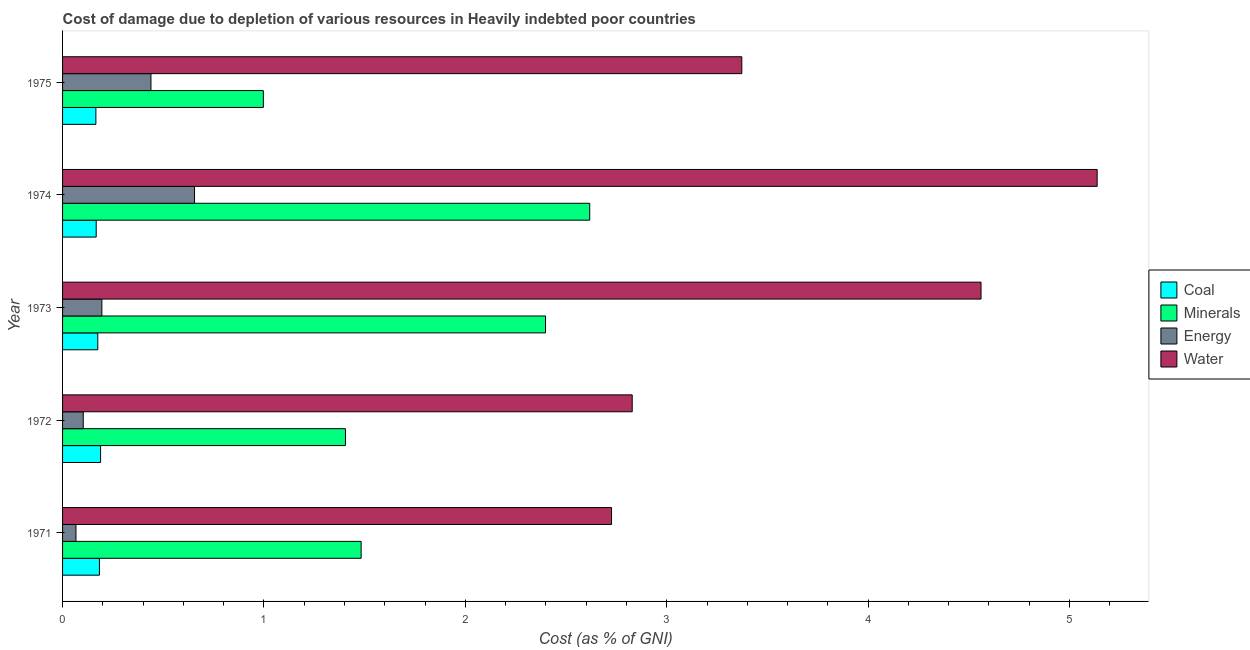How many groups of bars are there?
Your answer should be compact. 5. Are the number of bars on each tick of the Y-axis equal?
Make the answer very short. Yes. How many bars are there on the 3rd tick from the bottom?
Give a very brief answer. 4. In how many cases, is the number of bars for a given year not equal to the number of legend labels?
Offer a very short reply. 0. What is the cost of damage due to depletion of energy in 1975?
Ensure brevity in your answer.  0.44. Across all years, what is the maximum cost of damage due to depletion of energy?
Your answer should be very brief. 0.66. Across all years, what is the minimum cost of damage due to depletion of energy?
Ensure brevity in your answer.  0.07. In which year was the cost of damage due to depletion of water maximum?
Provide a short and direct response. 1974. What is the total cost of damage due to depletion of water in the graph?
Keep it short and to the point. 18.63. What is the difference between the cost of damage due to depletion of energy in 1972 and that in 1973?
Keep it short and to the point. -0.09. What is the difference between the cost of damage due to depletion of energy in 1972 and the cost of damage due to depletion of minerals in 1974?
Keep it short and to the point. -2.51. What is the average cost of damage due to depletion of minerals per year?
Keep it short and to the point. 1.78. In the year 1972, what is the difference between the cost of damage due to depletion of energy and cost of damage due to depletion of coal?
Give a very brief answer. -0.09. What is the ratio of the cost of damage due to depletion of coal in 1972 to that in 1974?
Keep it short and to the point. 1.13. Is the difference between the cost of damage due to depletion of minerals in 1972 and 1975 greater than the difference between the cost of damage due to depletion of energy in 1972 and 1975?
Give a very brief answer. Yes. What is the difference between the highest and the second highest cost of damage due to depletion of water?
Make the answer very short. 0.58. What is the difference between the highest and the lowest cost of damage due to depletion of water?
Keep it short and to the point. 2.41. In how many years, is the cost of damage due to depletion of coal greater than the average cost of damage due to depletion of coal taken over all years?
Make the answer very short. 2. Is the sum of the cost of damage due to depletion of energy in 1972 and 1975 greater than the maximum cost of damage due to depletion of minerals across all years?
Ensure brevity in your answer.  No. Is it the case that in every year, the sum of the cost of damage due to depletion of water and cost of damage due to depletion of energy is greater than the sum of cost of damage due to depletion of coal and cost of damage due to depletion of minerals?
Your answer should be very brief. Yes. What does the 2nd bar from the top in 1973 represents?
Your answer should be compact. Energy. What does the 3rd bar from the bottom in 1972 represents?
Give a very brief answer. Energy. How many years are there in the graph?
Provide a short and direct response. 5. Are the values on the major ticks of X-axis written in scientific E-notation?
Ensure brevity in your answer.  No. Does the graph contain any zero values?
Ensure brevity in your answer.  No. How many legend labels are there?
Offer a very short reply. 4. What is the title of the graph?
Provide a short and direct response. Cost of damage due to depletion of various resources in Heavily indebted poor countries . What is the label or title of the X-axis?
Your response must be concise. Cost (as % of GNI). What is the label or title of the Y-axis?
Keep it short and to the point. Year. What is the Cost (as % of GNI) in Coal in 1971?
Offer a terse response. 0.18. What is the Cost (as % of GNI) in Minerals in 1971?
Your answer should be very brief. 1.48. What is the Cost (as % of GNI) in Energy in 1971?
Make the answer very short. 0.07. What is the Cost (as % of GNI) in Water in 1971?
Your answer should be very brief. 2.73. What is the Cost (as % of GNI) in Coal in 1972?
Your answer should be compact. 0.19. What is the Cost (as % of GNI) in Minerals in 1972?
Your response must be concise. 1.4. What is the Cost (as % of GNI) in Energy in 1972?
Ensure brevity in your answer.  0.1. What is the Cost (as % of GNI) in Water in 1972?
Provide a short and direct response. 2.83. What is the Cost (as % of GNI) of Coal in 1973?
Provide a succinct answer. 0.17. What is the Cost (as % of GNI) in Minerals in 1973?
Your answer should be compact. 2.4. What is the Cost (as % of GNI) in Energy in 1973?
Your answer should be very brief. 0.2. What is the Cost (as % of GNI) of Water in 1973?
Keep it short and to the point. 4.56. What is the Cost (as % of GNI) of Coal in 1974?
Ensure brevity in your answer.  0.17. What is the Cost (as % of GNI) of Minerals in 1974?
Make the answer very short. 2.62. What is the Cost (as % of GNI) in Energy in 1974?
Keep it short and to the point. 0.66. What is the Cost (as % of GNI) of Water in 1974?
Your response must be concise. 5.14. What is the Cost (as % of GNI) of Coal in 1975?
Give a very brief answer. 0.17. What is the Cost (as % of GNI) in Minerals in 1975?
Your response must be concise. 1. What is the Cost (as % of GNI) in Energy in 1975?
Your answer should be compact. 0.44. What is the Cost (as % of GNI) of Water in 1975?
Keep it short and to the point. 3.37. Across all years, what is the maximum Cost (as % of GNI) of Coal?
Ensure brevity in your answer.  0.19. Across all years, what is the maximum Cost (as % of GNI) in Minerals?
Your answer should be very brief. 2.62. Across all years, what is the maximum Cost (as % of GNI) of Energy?
Make the answer very short. 0.66. Across all years, what is the maximum Cost (as % of GNI) of Water?
Your answer should be compact. 5.14. Across all years, what is the minimum Cost (as % of GNI) of Coal?
Give a very brief answer. 0.17. Across all years, what is the minimum Cost (as % of GNI) in Minerals?
Offer a terse response. 1. Across all years, what is the minimum Cost (as % of GNI) of Energy?
Offer a terse response. 0.07. Across all years, what is the minimum Cost (as % of GNI) of Water?
Provide a short and direct response. 2.73. What is the total Cost (as % of GNI) in Coal in the graph?
Your response must be concise. 0.88. What is the total Cost (as % of GNI) in Minerals in the graph?
Make the answer very short. 8.9. What is the total Cost (as % of GNI) in Energy in the graph?
Keep it short and to the point. 1.46. What is the total Cost (as % of GNI) of Water in the graph?
Your response must be concise. 18.63. What is the difference between the Cost (as % of GNI) in Coal in 1971 and that in 1972?
Keep it short and to the point. -0.01. What is the difference between the Cost (as % of GNI) of Minerals in 1971 and that in 1972?
Provide a short and direct response. 0.08. What is the difference between the Cost (as % of GNI) in Energy in 1971 and that in 1972?
Give a very brief answer. -0.04. What is the difference between the Cost (as % of GNI) of Water in 1971 and that in 1972?
Offer a very short reply. -0.1. What is the difference between the Cost (as % of GNI) of Coal in 1971 and that in 1973?
Your answer should be very brief. 0.01. What is the difference between the Cost (as % of GNI) of Minerals in 1971 and that in 1973?
Make the answer very short. -0.92. What is the difference between the Cost (as % of GNI) in Energy in 1971 and that in 1973?
Your answer should be very brief. -0.13. What is the difference between the Cost (as % of GNI) of Water in 1971 and that in 1973?
Give a very brief answer. -1.83. What is the difference between the Cost (as % of GNI) in Coal in 1971 and that in 1974?
Ensure brevity in your answer.  0.02. What is the difference between the Cost (as % of GNI) in Minerals in 1971 and that in 1974?
Provide a short and direct response. -1.14. What is the difference between the Cost (as % of GNI) in Energy in 1971 and that in 1974?
Keep it short and to the point. -0.59. What is the difference between the Cost (as % of GNI) in Water in 1971 and that in 1974?
Provide a short and direct response. -2.41. What is the difference between the Cost (as % of GNI) in Coal in 1971 and that in 1975?
Offer a very short reply. 0.02. What is the difference between the Cost (as % of GNI) in Minerals in 1971 and that in 1975?
Your answer should be compact. 0.49. What is the difference between the Cost (as % of GNI) of Energy in 1971 and that in 1975?
Your response must be concise. -0.37. What is the difference between the Cost (as % of GNI) in Water in 1971 and that in 1975?
Provide a short and direct response. -0.65. What is the difference between the Cost (as % of GNI) of Coal in 1972 and that in 1973?
Provide a short and direct response. 0.01. What is the difference between the Cost (as % of GNI) of Minerals in 1972 and that in 1973?
Your answer should be very brief. -0.99. What is the difference between the Cost (as % of GNI) in Energy in 1972 and that in 1973?
Keep it short and to the point. -0.09. What is the difference between the Cost (as % of GNI) of Water in 1972 and that in 1973?
Ensure brevity in your answer.  -1.73. What is the difference between the Cost (as % of GNI) in Coal in 1972 and that in 1974?
Your response must be concise. 0.02. What is the difference between the Cost (as % of GNI) of Minerals in 1972 and that in 1974?
Provide a short and direct response. -1.21. What is the difference between the Cost (as % of GNI) in Energy in 1972 and that in 1974?
Your response must be concise. -0.55. What is the difference between the Cost (as % of GNI) in Water in 1972 and that in 1974?
Provide a succinct answer. -2.31. What is the difference between the Cost (as % of GNI) of Coal in 1972 and that in 1975?
Your response must be concise. 0.02. What is the difference between the Cost (as % of GNI) in Minerals in 1972 and that in 1975?
Your answer should be compact. 0.41. What is the difference between the Cost (as % of GNI) in Energy in 1972 and that in 1975?
Ensure brevity in your answer.  -0.34. What is the difference between the Cost (as % of GNI) of Water in 1972 and that in 1975?
Keep it short and to the point. -0.54. What is the difference between the Cost (as % of GNI) of Coal in 1973 and that in 1974?
Your response must be concise. 0.01. What is the difference between the Cost (as % of GNI) of Minerals in 1973 and that in 1974?
Make the answer very short. -0.22. What is the difference between the Cost (as % of GNI) of Energy in 1973 and that in 1974?
Your answer should be very brief. -0.46. What is the difference between the Cost (as % of GNI) in Water in 1973 and that in 1974?
Ensure brevity in your answer.  -0.58. What is the difference between the Cost (as % of GNI) in Coal in 1973 and that in 1975?
Your answer should be very brief. 0.01. What is the difference between the Cost (as % of GNI) of Minerals in 1973 and that in 1975?
Keep it short and to the point. 1.4. What is the difference between the Cost (as % of GNI) of Energy in 1973 and that in 1975?
Make the answer very short. -0.24. What is the difference between the Cost (as % of GNI) in Water in 1973 and that in 1975?
Provide a succinct answer. 1.19. What is the difference between the Cost (as % of GNI) of Coal in 1974 and that in 1975?
Your answer should be very brief. 0. What is the difference between the Cost (as % of GNI) in Minerals in 1974 and that in 1975?
Make the answer very short. 1.62. What is the difference between the Cost (as % of GNI) of Energy in 1974 and that in 1975?
Provide a short and direct response. 0.22. What is the difference between the Cost (as % of GNI) of Water in 1974 and that in 1975?
Offer a terse response. 1.76. What is the difference between the Cost (as % of GNI) in Coal in 1971 and the Cost (as % of GNI) in Minerals in 1972?
Your answer should be very brief. -1.22. What is the difference between the Cost (as % of GNI) in Coal in 1971 and the Cost (as % of GNI) in Energy in 1972?
Provide a short and direct response. 0.08. What is the difference between the Cost (as % of GNI) in Coal in 1971 and the Cost (as % of GNI) in Water in 1972?
Ensure brevity in your answer.  -2.65. What is the difference between the Cost (as % of GNI) of Minerals in 1971 and the Cost (as % of GNI) of Energy in 1972?
Provide a succinct answer. 1.38. What is the difference between the Cost (as % of GNI) in Minerals in 1971 and the Cost (as % of GNI) in Water in 1972?
Offer a very short reply. -1.35. What is the difference between the Cost (as % of GNI) of Energy in 1971 and the Cost (as % of GNI) of Water in 1972?
Your response must be concise. -2.76. What is the difference between the Cost (as % of GNI) of Coal in 1971 and the Cost (as % of GNI) of Minerals in 1973?
Offer a very short reply. -2.21. What is the difference between the Cost (as % of GNI) in Coal in 1971 and the Cost (as % of GNI) in Energy in 1973?
Make the answer very short. -0.01. What is the difference between the Cost (as % of GNI) of Coal in 1971 and the Cost (as % of GNI) of Water in 1973?
Give a very brief answer. -4.38. What is the difference between the Cost (as % of GNI) in Minerals in 1971 and the Cost (as % of GNI) in Energy in 1973?
Ensure brevity in your answer.  1.29. What is the difference between the Cost (as % of GNI) of Minerals in 1971 and the Cost (as % of GNI) of Water in 1973?
Ensure brevity in your answer.  -3.08. What is the difference between the Cost (as % of GNI) in Energy in 1971 and the Cost (as % of GNI) in Water in 1973?
Provide a short and direct response. -4.49. What is the difference between the Cost (as % of GNI) in Coal in 1971 and the Cost (as % of GNI) in Minerals in 1974?
Give a very brief answer. -2.43. What is the difference between the Cost (as % of GNI) of Coal in 1971 and the Cost (as % of GNI) of Energy in 1974?
Provide a succinct answer. -0.47. What is the difference between the Cost (as % of GNI) in Coal in 1971 and the Cost (as % of GNI) in Water in 1974?
Provide a succinct answer. -4.95. What is the difference between the Cost (as % of GNI) in Minerals in 1971 and the Cost (as % of GNI) in Energy in 1974?
Provide a succinct answer. 0.83. What is the difference between the Cost (as % of GNI) in Minerals in 1971 and the Cost (as % of GNI) in Water in 1974?
Offer a terse response. -3.65. What is the difference between the Cost (as % of GNI) in Energy in 1971 and the Cost (as % of GNI) in Water in 1974?
Your answer should be very brief. -5.07. What is the difference between the Cost (as % of GNI) in Coal in 1971 and the Cost (as % of GNI) in Minerals in 1975?
Give a very brief answer. -0.81. What is the difference between the Cost (as % of GNI) in Coal in 1971 and the Cost (as % of GNI) in Energy in 1975?
Offer a very short reply. -0.26. What is the difference between the Cost (as % of GNI) in Coal in 1971 and the Cost (as % of GNI) in Water in 1975?
Your answer should be compact. -3.19. What is the difference between the Cost (as % of GNI) in Minerals in 1971 and the Cost (as % of GNI) in Energy in 1975?
Give a very brief answer. 1.04. What is the difference between the Cost (as % of GNI) in Minerals in 1971 and the Cost (as % of GNI) in Water in 1975?
Keep it short and to the point. -1.89. What is the difference between the Cost (as % of GNI) of Energy in 1971 and the Cost (as % of GNI) of Water in 1975?
Give a very brief answer. -3.31. What is the difference between the Cost (as % of GNI) of Coal in 1972 and the Cost (as % of GNI) of Minerals in 1973?
Your answer should be compact. -2.21. What is the difference between the Cost (as % of GNI) in Coal in 1972 and the Cost (as % of GNI) in Energy in 1973?
Offer a terse response. -0.01. What is the difference between the Cost (as % of GNI) of Coal in 1972 and the Cost (as % of GNI) of Water in 1973?
Provide a short and direct response. -4.37. What is the difference between the Cost (as % of GNI) in Minerals in 1972 and the Cost (as % of GNI) in Energy in 1973?
Keep it short and to the point. 1.21. What is the difference between the Cost (as % of GNI) in Minerals in 1972 and the Cost (as % of GNI) in Water in 1973?
Provide a short and direct response. -3.16. What is the difference between the Cost (as % of GNI) of Energy in 1972 and the Cost (as % of GNI) of Water in 1973?
Your response must be concise. -4.46. What is the difference between the Cost (as % of GNI) of Coal in 1972 and the Cost (as % of GNI) of Minerals in 1974?
Your answer should be compact. -2.43. What is the difference between the Cost (as % of GNI) of Coal in 1972 and the Cost (as % of GNI) of Energy in 1974?
Keep it short and to the point. -0.47. What is the difference between the Cost (as % of GNI) in Coal in 1972 and the Cost (as % of GNI) in Water in 1974?
Provide a succinct answer. -4.95. What is the difference between the Cost (as % of GNI) in Minerals in 1972 and the Cost (as % of GNI) in Energy in 1974?
Ensure brevity in your answer.  0.75. What is the difference between the Cost (as % of GNI) of Minerals in 1972 and the Cost (as % of GNI) of Water in 1974?
Make the answer very short. -3.73. What is the difference between the Cost (as % of GNI) in Energy in 1972 and the Cost (as % of GNI) in Water in 1974?
Your answer should be compact. -5.03. What is the difference between the Cost (as % of GNI) of Coal in 1972 and the Cost (as % of GNI) of Minerals in 1975?
Ensure brevity in your answer.  -0.81. What is the difference between the Cost (as % of GNI) in Coal in 1972 and the Cost (as % of GNI) in Energy in 1975?
Ensure brevity in your answer.  -0.25. What is the difference between the Cost (as % of GNI) of Coal in 1972 and the Cost (as % of GNI) of Water in 1975?
Your answer should be very brief. -3.18. What is the difference between the Cost (as % of GNI) in Minerals in 1972 and the Cost (as % of GNI) in Energy in 1975?
Your response must be concise. 0.97. What is the difference between the Cost (as % of GNI) of Minerals in 1972 and the Cost (as % of GNI) of Water in 1975?
Your answer should be compact. -1.97. What is the difference between the Cost (as % of GNI) in Energy in 1972 and the Cost (as % of GNI) in Water in 1975?
Keep it short and to the point. -3.27. What is the difference between the Cost (as % of GNI) of Coal in 1973 and the Cost (as % of GNI) of Minerals in 1974?
Your answer should be compact. -2.44. What is the difference between the Cost (as % of GNI) in Coal in 1973 and the Cost (as % of GNI) in Energy in 1974?
Your answer should be compact. -0.48. What is the difference between the Cost (as % of GNI) in Coal in 1973 and the Cost (as % of GNI) in Water in 1974?
Provide a succinct answer. -4.96. What is the difference between the Cost (as % of GNI) of Minerals in 1973 and the Cost (as % of GNI) of Energy in 1974?
Your answer should be very brief. 1.74. What is the difference between the Cost (as % of GNI) in Minerals in 1973 and the Cost (as % of GNI) in Water in 1974?
Keep it short and to the point. -2.74. What is the difference between the Cost (as % of GNI) in Energy in 1973 and the Cost (as % of GNI) in Water in 1974?
Offer a terse response. -4.94. What is the difference between the Cost (as % of GNI) of Coal in 1973 and the Cost (as % of GNI) of Minerals in 1975?
Your answer should be very brief. -0.82. What is the difference between the Cost (as % of GNI) in Coal in 1973 and the Cost (as % of GNI) in Energy in 1975?
Your response must be concise. -0.26. What is the difference between the Cost (as % of GNI) in Coal in 1973 and the Cost (as % of GNI) in Water in 1975?
Offer a terse response. -3.2. What is the difference between the Cost (as % of GNI) of Minerals in 1973 and the Cost (as % of GNI) of Energy in 1975?
Give a very brief answer. 1.96. What is the difference between the Cost (as % of GNI) of Minerals in 1973 and the Cost (as % of GNI) of Water in 1975?
Keep it short and to the point. -0.97. What is the difference between the Cost (as % of GNI) of Energy in 1973 and the Cost (as % of GNI) of Water in 1975?
Your answer should be very brief. -3.18. What is the difference between the Cost (as % of GNI) in Coal in 1974 and the Cost (as % of GNI) in Minerals in 1975?
Your answer should be very brief. -0.83. What is the difference between the Cost (as % of GNI) in Coal in 1974 and the Cost (as % of GNI) in Energy in 1975?
Make the answer very short. -0.27. What is the difference between the Cost (as % of GNI) in Coal in 1974 and the Cost (as % of GNI) in Water in 1975?
Give a very brief answer. -3.21. What is the difference between the Cost (as % of GNI) of Minerals in 1974 and the Cost (as % of GNI) of Energy in 1975?
Ensure brevity in your answer.  2.18. What is the difference between the Cost (as % of GNI) of Minerals in 1974 and the Cost (as % of GNI) of Water in 1975?
Your answer should be compact. -0.76. What is the difference between the Cost (as % of GNI) in Energy in 1974 and the Cost (as % of GNI) in Water in 1975?
Your answer should be compact. -2.72. What is the average Cost (as % of GNI) in Coal per year?
Your response must be concise. 0.18. What is the average Cost (as % of GNI) of Minerals per year?
Make the answer very short. 1.78. What is the average Cost (as % of GNI) of Energy per year?
Keep it short and to the point. 0.29. What is the average Cost (as % of GNI) of Water per year?
Your response must be concise. 3.73. In the year 1971, what is the difference between the Cost (as % of GNI) of Coal and Cost (as % of GNI) of Minerals?
Give a very brief answer. -1.3. In the year 1971, what is the difference between the Cost (as % of GNI) of Coal and Cost (as % of GNI) of Energy?
Provide a short and direct response. 0.12. In the year 1971, what is the difference between the Cost (as % of GNI) of Coal and Cost (as % of GNI) of Water?
Provide a short and direct response. -2.54. In the year 1971, what is the difference between the Cost (as % of GNI) of Minerals and Cost (as % of GNI) of Energy?
Give a very brief answer. 1.42. In the year 1971, what is the difference between the Cost (as % of GNI) in Minerals and Cost (as % of GNI) in Water?
Offer a terse response. -1.24. In the year 1971, what is the difference between the Cost (as % of GNI) in Energy and Cost (as % of GNI) in Water?
Ensure brevity in your answer.  -2.66. In the year 1972, what is the difference between the Cost (as % of GNI) of Coal and Cost (as % of GNI) of Minerals?
Provide a short and direct response. -1.22. In the year 1972, what is the difference between the Cost (as % of GNI) of Coal and Cost (as % of GNI) of Energy?
Your answer should be very brief. 0.09. In the year 1972, what is the difference between the Cost (as % of GNI) of Coal and Cost (as % of GNI) of Water?
Give a very brief answer. -2.64. In the year 1972, what is the difference between the Cost (as % of GNI) of Minerals and Cost (as % of GNI) of Energy?
Provide a short and direct response. 1.3. In the year 1972, what is the difference between the Cost (as % of GNI) in Minerals and Cost (as % of GNI) in Water?
Offer a very short reply. -1.42. In the year 1972, what is the difference between the Cost (as % of GNI) of Energy and Cost (as % of GNI) of Water?
Offer a terse response. -2.73. In the year 1973, what is the difference between the Cost (as % of GNI) in Coal and Cost (as % of GNI) in Minerals?
Keep it short and to the point. -2.22. In the year 1973, what is the difference between the Cost (as % of GNI) in Coal and Cost (as % of GNI) in Energy?
Ensure brevity in your answer.  -0.02. In the year 1973, what is the difference between the Cost (as % of GNI) of Coal and Cost (as % of GNI) of Water?
Provide a succinct answer. -4.39. In the year 1973, what is the difference between the Cost (as % of GNI) of Minerals and Cost (as % of GNI) of Energy?
Your answer should be very brief. 2.2. In the year 1973, what is the difference between the Cost (as % of GNI) of Minerals and Cost (as % of GNI) of Water?
Offer a very short reply. -2.16. In the year 1973, what is the difference between the Cost (as % of GNI) of Energy and Cost (as % of GNI) of Water?
Give a very brief answer. -4.37. In the year 1974, what is the difference between the Cost (as % of GNI) of Coal and Cost (as % of GNI) of Minerals?
Offer a very short reply. -2.45. In the year 1974, what is the difference between the Cost (as % of GNI) of Coal and Cost (as % of GNI) of Energy?
Provide a succinct answer. -0.49. In the year 1974, what is the difference between the Cost (as % of GNI) in Coal and Cost (as % of GNI) in Water?
Offer a very short reply. -4.97. In the year 1974, what is the difference between the Cost (as % of GNI) in Minerals and Cost (as % of GNI) in Energy?
Make the answer very short. 1.96. In the year 1974, what is the difference between the Cost (as % of GNI) of Minerals and Cost (as % of GNI) of Water?
Your response must be concise. -2.52. In the year 1974, what is the difference between the Cost (as % of GNI) of Energy and Cost (as % of GNI) of Water?
Ensure brevity in your answer.  -4.48. In the year 1975, what is the difference between the Cost (as % of GNI) of Coal and Cost (as % of GNI) of Minerals?
Provide a succinct answer. -0.83. In the year 1975, what is the difference between the Cost (as % of GNI) in Coal and Cost (as % of GNI) in Energy?
Offer a terse response. -0.27. In the year 1975, what is the difference between the Cost (as % of GNI) of Coal and Cost (as % of GNI) of Water?
Keep it short and to the point. -3.21. In the year 1975, what is the difference between the Cost (as % of GNI) of Minerals and Cost (as % of GNI) of Energy?
Your answer should be compact. 0.56. In the year 1975, what is the difference between the Cost (as % of GNI) of Minerals and Cost (as % of GNI) of Water?
Offer a terse response. -2.38. In the year 1975, what is the difference between the Cost (as % of GNI) in Energy and Cost (as % of GNI) in Water?
Provide a short and direct response. -2.93. What is the ratio of the Cost (as % of GNI) in Coal in 1971 to that in 1972?
Give a very brief answer. 0.97. What is the ratio of the Cost (as % of GNI) in Minerals in 1971 to that in 1972?
Ensure brevity in your answer.  1.06. What is the ratio of the Cost (as % of GNI) of Energy in 1971 to that in 1972?
Offer a terse response. 0.65. What is the ratio of the Cost (as % of GNI) of Water in 1971 to that in 1972?
Provide a succinct answer. 0.96. What is the ratio of the Cost (as % of GNI) in Coal in 1971 to that in 1973?
Give a very brief answer. 1.05. What is the ratio of the Cost (as % of GNI) of Minerals in 1971 to that in 1973?
Make the answer very short. 0.62. What is the ratio of the Cost (as % of GNI) in Energy in 1971 to that in 1973?
Give a very brief answer. 0.34. What is the ratio of the Cost (as % of GNI) in Water in 1971 to that in 1973?
Your answer should be compact. 0.6. What is the ratio of the Cost (as % of GNI) in Coal in 1971 to that in 1974?
Give a very brief answer. 1.1. What is the ratio of the Cost (as % of GNI) of Minerals in 1971 to that in 1974?
Provide a short and direct response. 0.57. What is the ratio of the Cost (as % of GNI) in Energy in 1971 to that in 1974?
Provide a short and direct response. 0.1. What is the ratio of the Cost (as % of GNI) of Water in 1971 to that in 1974?
Offer a very short reply. 0.53. What is the ratio of the Cost (as % of GNI) in Coal in 1971 to that in 1975?
Make the answer very short. 1.11. What is the ratio of the Cost (as % of GNI) of Minerals in 1971 to that in 1975?
Provide a short and direct response. 1.49. What is the ratio of the Cost (as % of GNI) in Energy in 1971 to that in 1975?
Make the answer very short. 0.15. What is the ratio of the Cost (as % of GNI) of Water in 1971 to that in 1975?
Provide a succinct answer. 0.81. What is the ratio of the Cost (as % of GNI) in Coal in 1972 to that in 1973?
Offer a terse response. 1.08. What is the ratio of the Cost (as % of GNI) of Minerals in 1972 to that in 1973?
Provide a short and direct response. 0.59. What is the ratio of the Cost (as % of GNI) of Energy in 1972 to that in 1973?
Provide a succinct answer. 0.53. What is the ratio of the Cost (as % of GNI) of Water in 1972 to that in 1973?
Offer a very short reply. 0.62. What is the ratio of the Cost (as % of GNI) of Coal in 1972 to that in 1974?
Make the answer very short. 1.13. What is the ratio of the Cost (as % of GNI) of Minerals in 1972 to that in 1974?
Offer a very short reply. 0.54. What is the ratio of the Cost (as % of GNI) in Energy in 1972 to that in 1974?
Give a very brief answer. 0.16. What is the ratio of the Cost (as % of GNI) of Water in 1972 to that in 1974?
Make the answer very short. 0.55. What is the ratio of the Cost (as % of GNI) of Coal in 1972 to that in 1975?
Your answer should be very brief. 1.14. What is the ratio of the Cost (as % of GNI) of Minerals in 1972 to that in 1975?
Ensure brevity in your answer.  1.41. What is the ratio of the Cost (as % of GNI) in Energy in 1972 to that in 1975?
Provide a succinct answer. 0.23. What is the ratio of the Cost (as % of GNI) of Water in 1972 to that in 1975?
Provide a succinct answer. 0.84. What is the ratio of the Cost (as % of GNI) in Coal in 1973 to that in 1974?
Offer a terse response. 1.05. What is the ratio of the Cost (as % of GNI) of Minerals in 1973 to that in 1974?
Provide a succinct answer. 0.92. What is the ratio of the Cost (as % of GNI) of Energy in 1973 to that in 1974?
Offer a very short reply. 0.3. What is the ratio of the Cost (as % of GNI) in Water in 1973 to that in 1974?
Your answer should be compact. 0.89. What is the ratio of the Cost (as % of GNI) in Coal in 1973 to that in 1975?
Your response must be concise. 1.06. What is the ratio of the Cost (as % of GNI) of Minerals in 1973 to that in 1975?
Your answer should be very brief. 2.41. What is the ratio of the Cost (as % of GNI) in Energy in 1973 to that in 1975?
Offer a very short reply. 0.44. What is the ratio of the Cost (as % of GNI) of Water in 1973 to that in 1975?
Your answer should be compact. 1.35. What is the ratio of the Cost (as % of GNI) of Coal in 1974 to that in 1975?
Your answer should be very brief. 1.01. What is the ratio of the Cost (as % of GNI) of Minerals in 1974 to that in 1975?
Offer a terse response. 2.63. What is the ratio of the Cost (as % of GNI) of Energy in 1974 to that in 1975?
Ensure brevity in your answer.  1.49. What is the ratio of the Cost (as % of GNI) in Water in 1974 to that in 1975?
Provide a succinct answer. 1.52. What is the difference between the highest and the second highest Cost (as % of GNI) in Coal?
Your answer should be very brief. 0.01. What is the difference between the highest and the second highest Cost (as % of GNI) of Minerals?
Your response must be concise. 0.22. What is the difference between the highest and the second highest Cost (as % of GNI) of Energy?
Ensure brevity in your answer.  0.22. What is the difference between the highest and the second highest Cost (as % of GNI) in Water?
Provide a succinct answer. 0.58. What is the difference between the highest and the lowest Cost (as % of GNI) of Coal?
Provide a short and direct response. 0.02. What is the difference between the highest and the lowest Cost (as % of GNI) in Minerals?
Keep it short and to the point. 1.62. What is the difference between the highest and the lowest Cost (as % of GNI) of Energy?
Make the answer very short. 0.59. What is the difference between the highest and the lowest Cost (as % of GNI) of Water?
Your answer should be very brief. 2.41. 